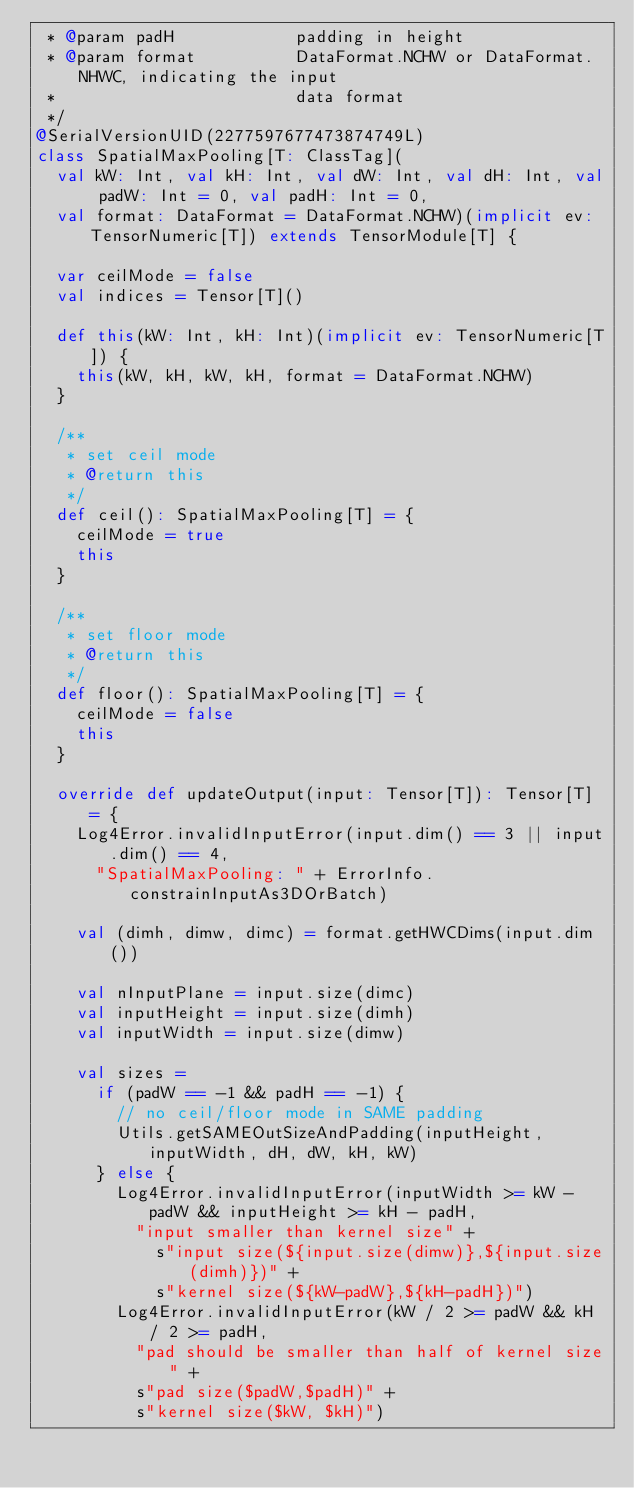<code> <loc_0><loc_0><loc_500><loc_500><_Scala_> * @param padH            padding in height
 * @param format          DataFormat.NCHW or DataFormat.NHWC, indicating the input
 *                        data format
 */
@SerialVersionUID(2277597677473874749L)
class SpatialMaxPooling[T: ClassTag](
  val kW: Int, val kH: Int, val dW: Int, val dH: Int, val padW: Int = 0, val padH: Int = 0,
  val format: DataFormat = DataFormat.NCHW)(implicit ev: TensorNumeric[T]) extends TensorModule[T] {

  var ceilMode = false
  val indices = Tensor[T]()

  def this(kW: Int, kH: Int)(implicit ev: TensorNumeric[T]) {
    this(kW, kH, kW, kH, format = DataFormat.NCHW)
  }

  /**
   * set ceil mode
   * @return this
   */
  def ceil(): SpatialMaxPooling[T] = {
    ceilMode = true
    this
  }

  /**
   * set floor mode
   * @return this
   */
  def floor(): SpatialMaxPooling[T] = {
    ceilMode = false
    this
  }

  override def updateOutput(input: Tensor[T]): Tensor[T] = {
    Log4Error.invalidInputError(input.dim() == 3 || input.dim() == 4,
      "SpatialMaxPooling: " + ErrorInfo.constrainInputAs3DOrBatch)

    val (dimh, dimw, dimc) = format.getHWCDims(input.dim())

    val nInputPlane = input.size(dimc)
    val inputHeight = input.size(dimh)
    val inputWidth = input.size(dimw)

    val sizes =
      if (padW == -1 && padH == -1) {
        // no ceil/floor mode in SAME padding
        Utils.getSAMEOutSizeAndPadding(inputHeight, inputWidth, dH, dW, kH, kW)
      } else {
        Log4Error.invalidInputError(inputWidth >= kW - padW && inputHeight >= kH - padH,
          "input smaller than kernel size" +
            s"input size(${input.size(dimw)},${input.size(dimh)})" +
            s"kernel size(${kW-padW},${kH-padH})")
        Log4Error.invalidInputError(kW / 2 >= padW && kH / 2 >= padH,
          "pad should be smaller than half of kernel size" +
          s"pad size($padW,$padH)" +
          s"kernel size($kW, $kH)")</code> 